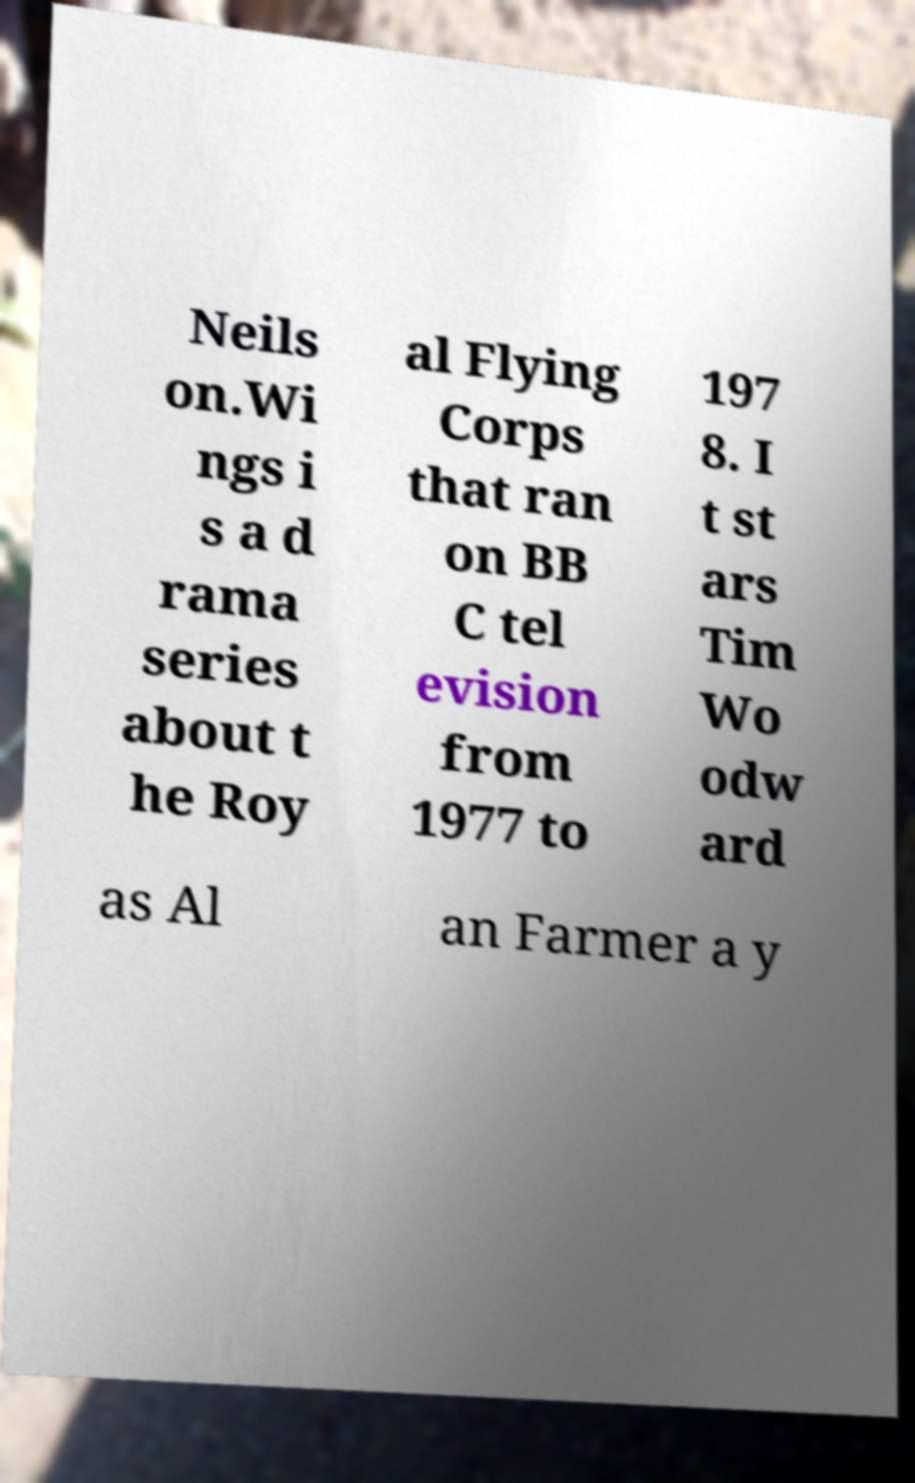Please read and relay the text visible in this image. What does it say? Neils on.Wi ngs i s a d rama series about t he Roy al Flying Corps that ran on BB C tel evision from 1977 to 197 8. I t st ars Tim Wo odw ard as Al an Farmer a y 